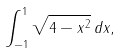<formula> <loc_0><loc_0><loc_500><loc_500>\int _ { - 1 } ^ { 1 } { \sqrt { 4 - x ^ { 2 } } } \, d x ,</formula> 